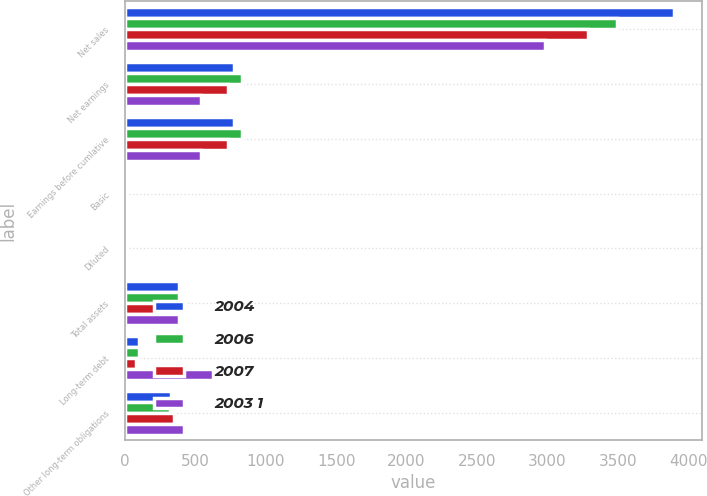Convert chart. <chart><loc_0><loc_0><loc_500><loc_500><stacked_bar_chart><ecel><fcel>Net sales<fcel>Net earnings<fcel>Earnings before cumlative<fcel>Basic<fcel>Diluted<fcel>Total assets<fcel>Long-term debt<fcel>Other long-term obligations<nl><fcel>2004<fcel>3897.5<fcel>773.2<fcel>773.2<fcel>3.28<fcel>3.26<fcel>384.6<fcel>104.3<fcel>328.4<nl><fcel>2006<fcel>3495.4<fcel>834.5<fcel>834.5<fcel>3.43<fcel>3.4<fcel>384.6<fcel>99.6<fcel>323.4<nl><fcel>2007<fcel>3286.1<fcel>732.5<fcel>732.5<fcel>2.96<fcel>2.93<fcel>384.6<fcel>81.6<fcel>348.3<nl><fcel>2003 1<fcel>2980.9<fcel>541.8<fcel>541.8<fcel>2.22<fcel>2.19<fcel>384.6<fcel>624<fcel>420.9<nl></chart> 